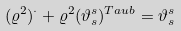<formula> <loc_0><loc_0><loc_500><loc_500>( \varrho ^ { 2 } ) ^ { \cdot } + \varrho ^ { 2 } ( \vartheta ^ { s } _ { s } ) ^ { T a u b } = \vartheta ^ { s } _ { s }</formula> 